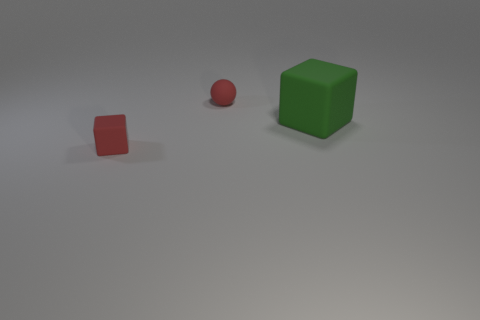Does the small cube have the same color as the ball?
Your answer should be very brief. Yes. The tiny matte thing that is the same color as the small matte sphere is what shape?
Offer a very short reply. Cube. There is a big green object that is the same material as the red ball; what is its shape?
Make the answer very short. Cube. There is a red matte thing that is on the left side of the tiny rubber object behind the tiny cube; are there any green matte cubes to the right of it?
Keep it short and to the point. Yes. What number of matte cubes are behind the green object?
Make the answer very short. 0. How many matte objects have the same color as the tiny rubber cube?
Keep it short and to the point. 1. What number of objects are either tiny red things that are in front of the red sphere or tiny rubber things in front of the big matte thing?
Offer a very short reply. 1. Is the number of large green things greater than the number of small things?
Provide a succinct answer. No. There is a matte object that is in front of the large matte block; what color is it?
Offer a terse response. Red. What is the color of the object that is in front of the matte ball and on the left side of the big green cube?
Give a very brief answer. Red. 